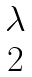<formula> <loc_0><loc_0><loc_500><loc_500>\begin{matrix} \lambda \\ 2 \end{matrix}</formula> 